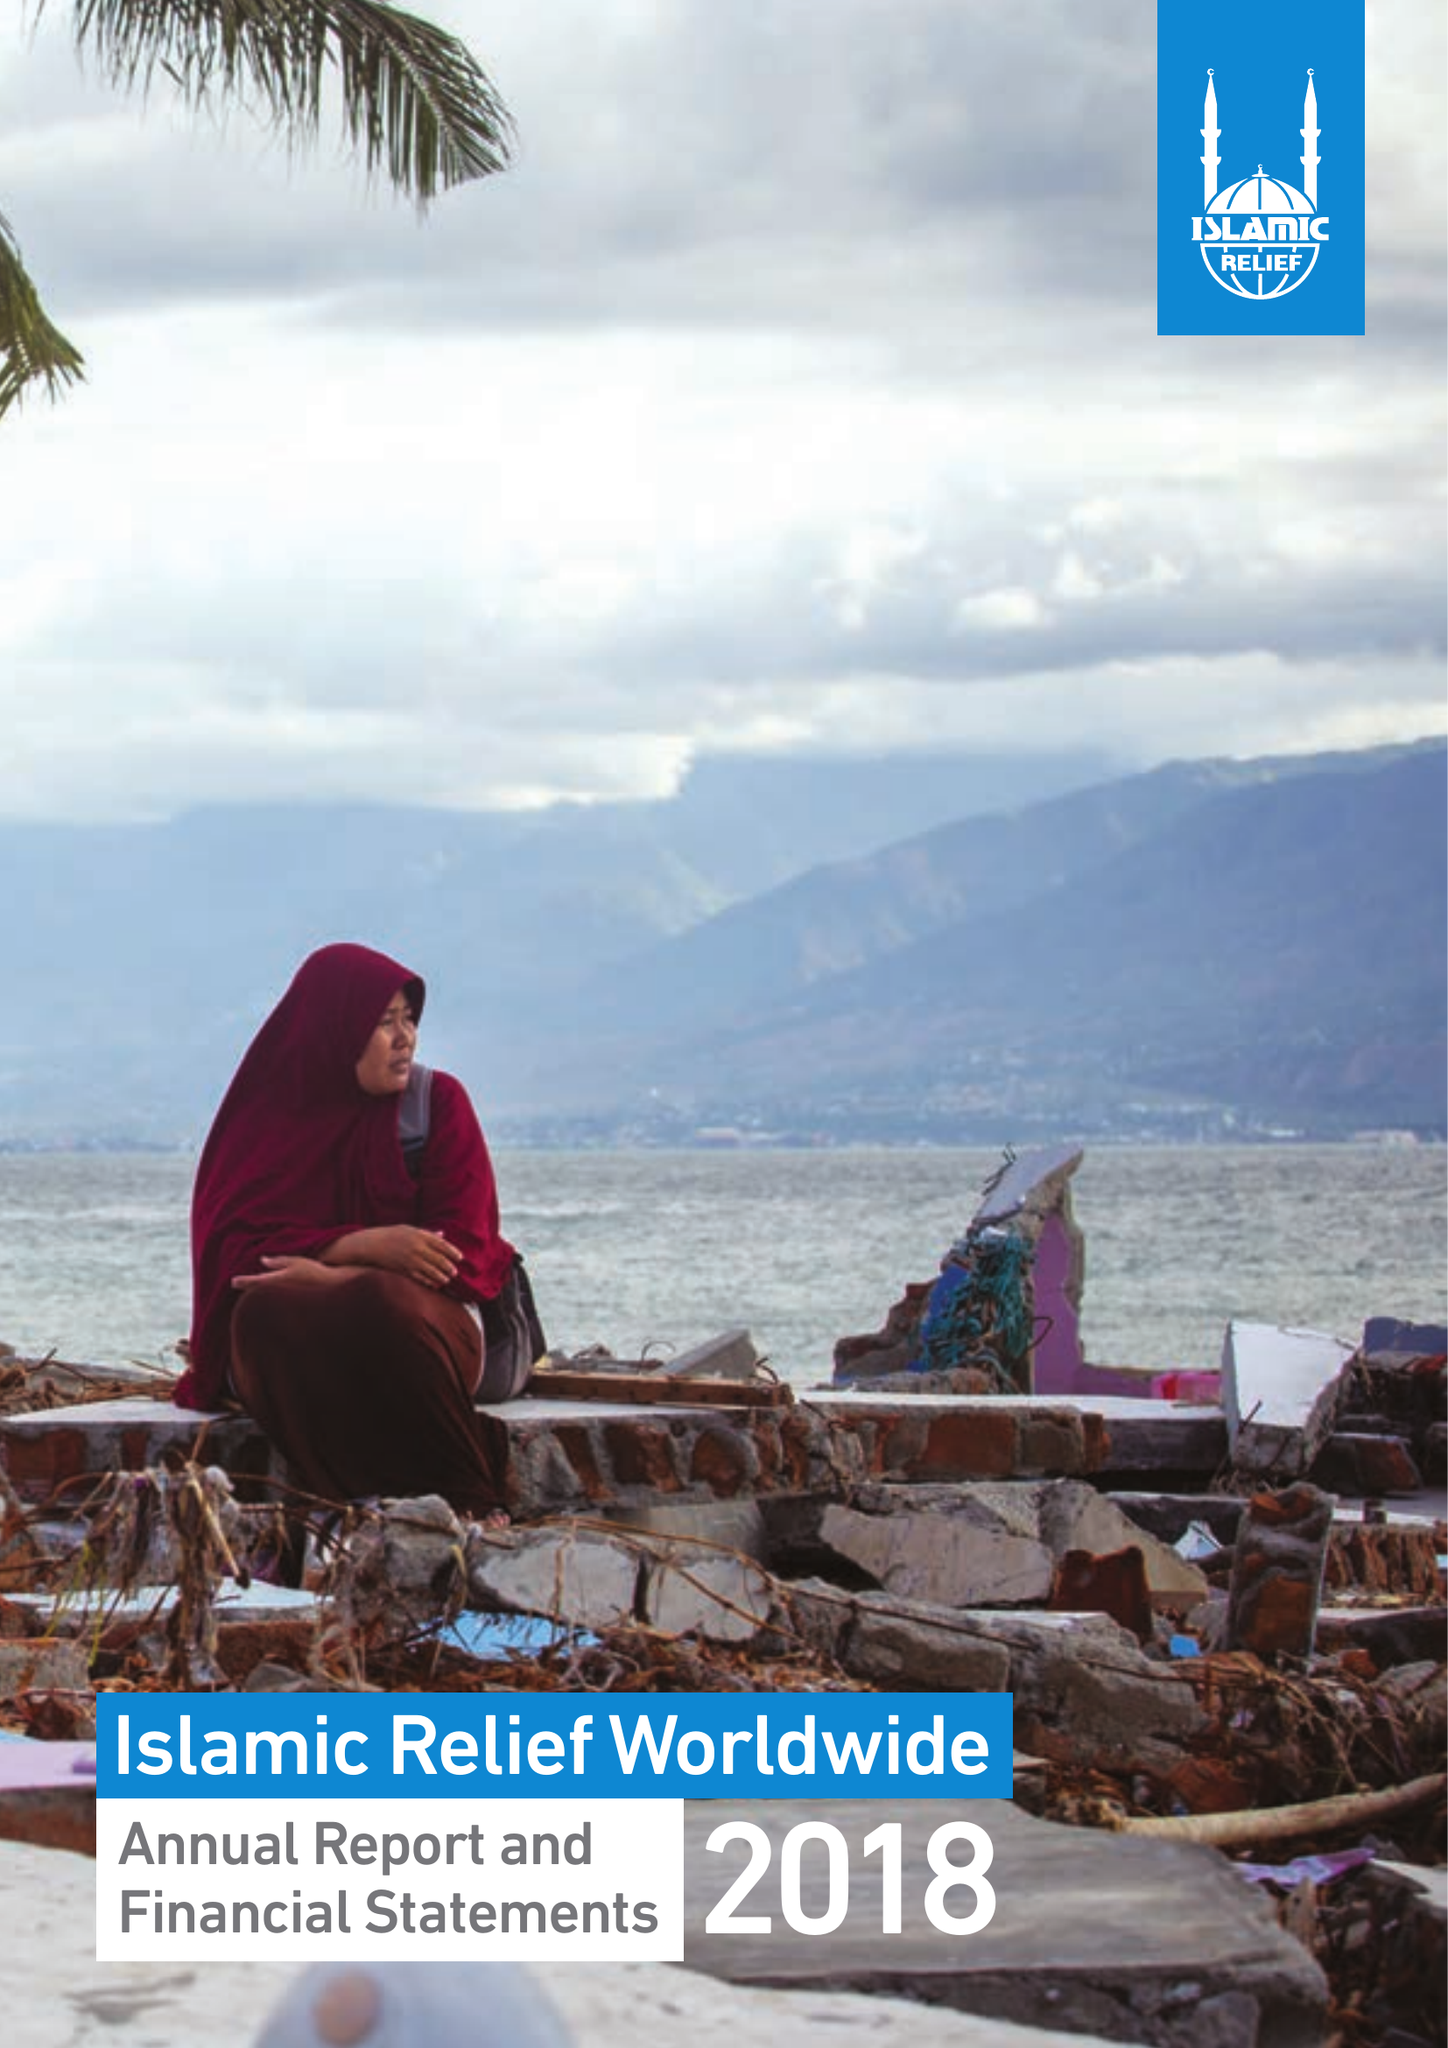What is the value for the spending_annually_in_british_pounds?
Answer the question using a single word or phrase. 128562290.00 